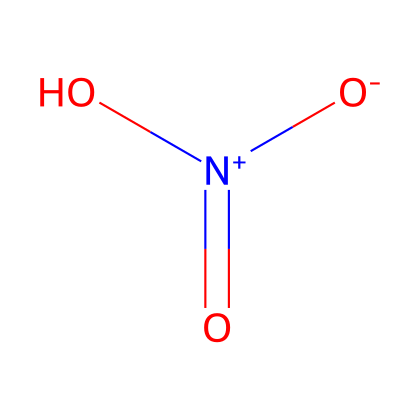What is the chemical name of this compound? The SMILES representation corresponds to a compound that features nitrogen and oxygen in its structure, commonly known as nitric acid.
Answer: nitric acid How many oxygen atoms are present in this molecule? Reviewing the SMILES representation shows three oxygen atoms featured in the structure surrounding the nitrogen atom.
Answer: 3 What type of acid is represented by this structure? The chemical structure indicates that it contains a proton donor and is classified as a strong acid, specifically an inorganic acid.
Answer: inorganic acid What is the oxidation state of nitrogen in this compound? By analyzing the connectivity and the presence of charged functional groups in the structure, we can determine that nitrogen in this representation is in the +5 oxidation state.
Answer: +5 What functional groups are found in nitric acid? The structure reveals that nitric acid contains both hydroxyl (-OH) and nitro (-NO2) groups within its molecular framework.
Answer: hydroxyl and nitro groups What is the primary use of this acid as inferred from its composition? Given that nitric acid is used in various industrial applications, particularly in the production of explosives such as TNT during the late 19th century, we can conclude its primary use is in explosives manufacturing.
Answer: explosives production 